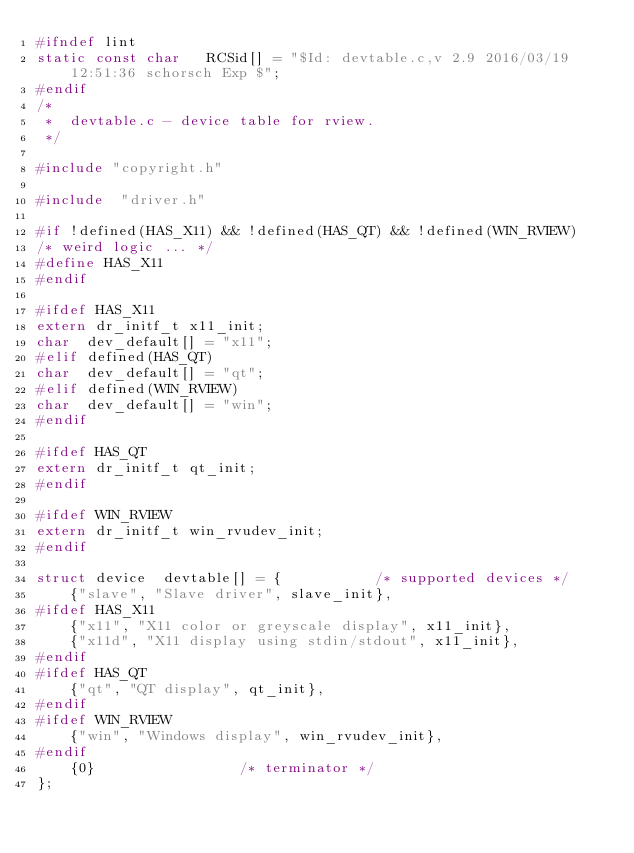<code> <loc_0><loc_0><loc_500><loc_500><_C_>#ifndef lint
static const char	RCSid[] = "$Id: devtable.c,v 2.9 2016/03/19 12:51:36 schorsch Exp $";
#endif
/*
 *  devtable.c - device table for rview.
 */

#include "copyright.h"

#include  "driver.h"

#if !defined(HAS_X11) && !defined(HAS_QT) && !defined(WIN_RVIEW)
/* weird logic ... */
#define HAS_X11
#endif

#ifdef HAS_X11
extern dr_initf_t x11_init;
char  dev_default[] = "x11";
#elif defined(HAS_QT)
char  dev_default[] = "qt";
#elif defined(WIN_RVIEW)
char  dev_default[] = "win";
#endif

#ifdef HAS_QT
extern dr_initf_t qt_init;
#endif

#ifdef WIN_RVIEW
extern dr_initf_t win_rvudev_init;
#endif

struct device  devtable[] = {			/* supported devices */
	{"slave", "Slave driver", slave_init},
#ifdef HAS_X11
	{"x11", "X11 color or greyscale display", x11_init},
	{"x11d", "X11 display using stdin/stdout", x11_init},
#endif
#ifdef HAS_QT
	{"qt", "QT display", qt_init},
#endif
#ifdef WIN_RVIEW
	{"win", "Windows display", win_rvudev_init},
#endif
	{0}					/* terminator */
};
</code> 